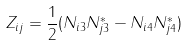<formula> <loc_0><loc_0><loc_500><loc_500>Z _ { i j } = \frac { 1 } { 2 } ( N _ { i 3 } N _ { j 3 } ^ { \ast } - N _ { i 4 } N _ { j 4 } ^ { \ast } )</formula> 